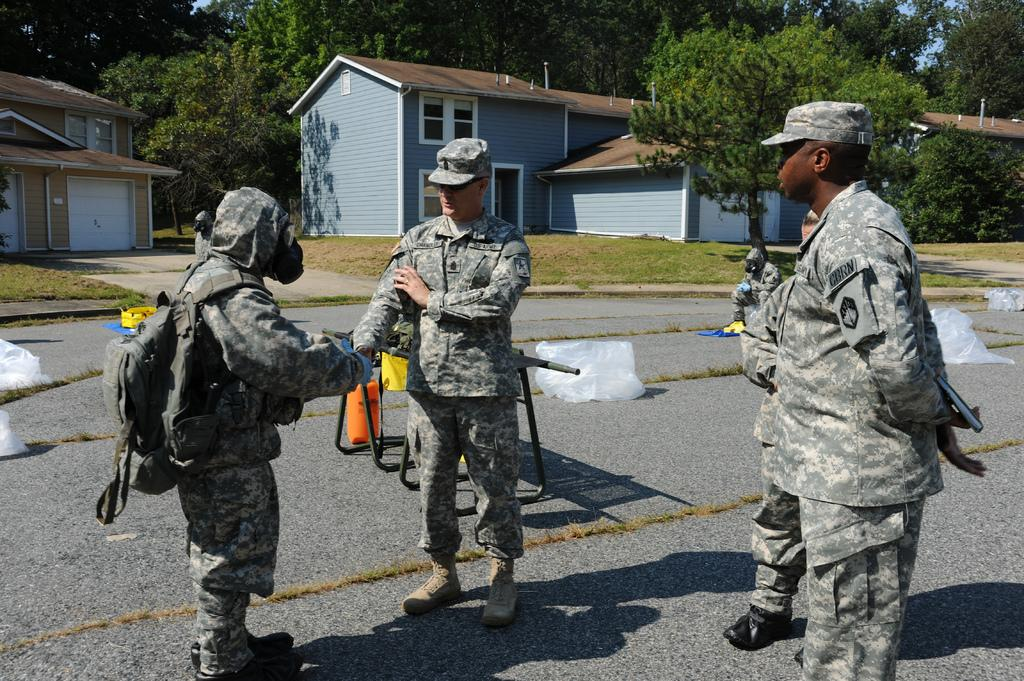What can be seen in the image in terms of human presence? There are people standing in the image. What type of natural environment is visible in the image? There is grass visible in the image. What type of furniture is present in the image? There is a table in the image. What type of structures can be seen in the image? There are houses in the image. What type of vegetation is present in the image? There are trees in the image. What type of cakes are being served by the people in the image? There is no mention of cakes or any food items in the image. How does the behavior of the people in the image reflect their relationship with their partner? There is no information about relationships or partners in the image. 